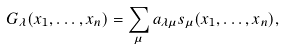<formula> <loc_0><loc_0><loc_500><loc_500>G _ { \lambda } ( x _ { 1 } , \dots , x _ { n } ) = \sum _ { \mu } a _ { \lambda \mu } s _ { \mu } ( x _ { 1 } , \dots , x _ { n } ) ,</formula> 